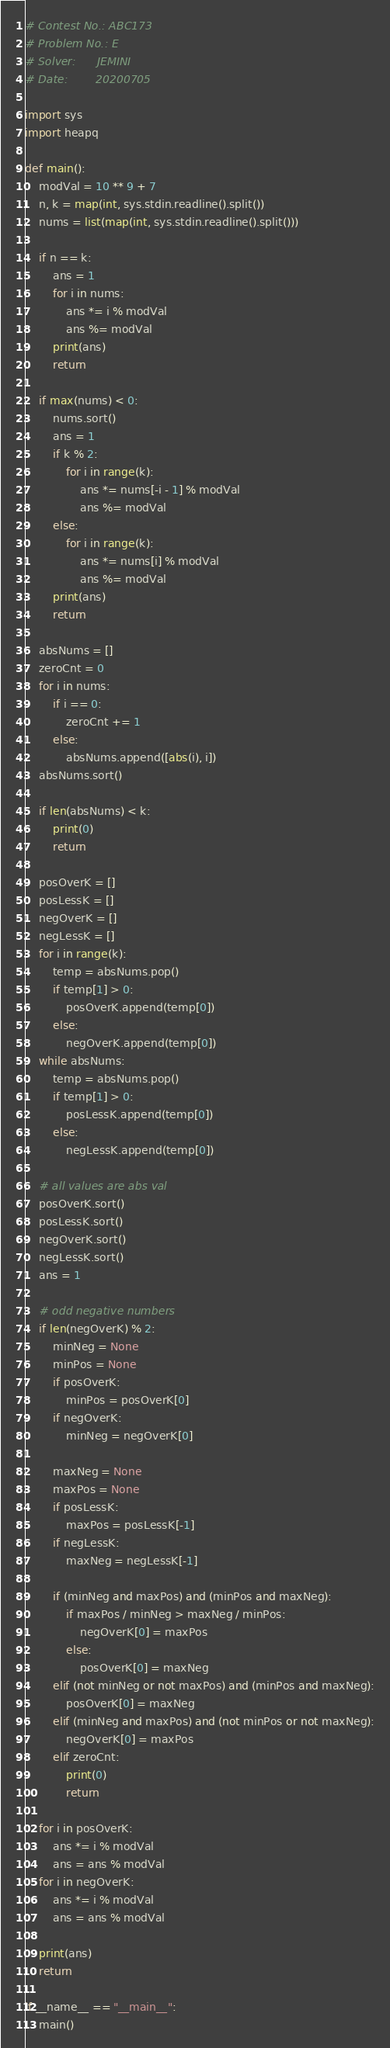Convert code to text. <code><loc_0><loc_0><loc_500><loc_500><_Python_># Contest No.: ABC173
# Problem No.: E
# Solver:      JEMINI
# Date:        20200705

import sys
import heapq

def main():
    modVal = 10 ** 9 + 7
    n, k = map(int, sys.stdin.readline().split())
    nums = list(map(int, sys.stdin.readline().split()))
    
    if n == k:
        ans = 1
        for i in nums:
            ans *= i % modVal
            ans %= modVal
        print(ans)
        return

    if max(nums) < 0:
        nums.sort()
        ans = 1
        if k % 2:
            for i in range(k):
                ans *= nums[-i - 1] % modVal
                ans %= modVal
        else:
            for i in range(k):
                ans *= nums[i] % modVal
                ans %= modVal
        print(ans)
        return
    
    absNums = []
    zeroCnt = 0
    for i in nums:
        if i == 0:
            zeroCnt += 1
        else:
            absNums.append([abs(i), i])
    absNums.sort()
    
    if len(absNums) < k:
        print(0)
        return

    posOverK = []
    posLessK = []
    negOverK = []
    negLessK = []
    for i in range(k):
        temp = absNums.pop()
        if temp[1] > 0:
            posOverK.append(temp[0])
        else:
            negOverK.append(temp[0])
    while absNums:
        temp = absNums.pop()
        if temp[1] > 0:
            posLessK.append(temp[0])
        else:
            negLessK.append(temp[0])
    
    # all values are abs val
    posOverK.sort()
    posLessK.sort()
    negOverK.sort()
    negLessK.sort()
    ans = 1

    # odd negative numbers
    if len(negOverK) % 2:
        minNeg = None
        minPos = None
        if posOverK:
            minPos = posOverK[0]
        if negOverK:
            minNeg = negOverK[0]

        maxNeg = None
        maxPos = None
        if posLessK:
            maxPos = posLessK[-1]
        if negLessK:
            maxNeg = negLessK[-1]
        
        if (minNeg and maxPos) and (minPos and maxNeg):
            if maxPos / minNeg > maxNeg / minPos:
                negOverK[0] = maxPos
            else:
                posOverK[0] = maxNeg
        elif (not minNeg or not maxPos) and (minPos and maxNeg):
            posOverK[0] = maxNeg
        elif (minNeg and maxPos) and (not minPos or not maxNeg):
            negOverK[0] = maxPos
        elif zeroCnt:
            print(0)
            return
    
    for i in posOverK:
        ans *= i % modVal
        ans = ans % modVal
    for i in negOverK:
        ans *= i % modVal
        ans = ans % modVal
    
    print(ans)
    return

if __name__ == "__main__":
    main()</code> 